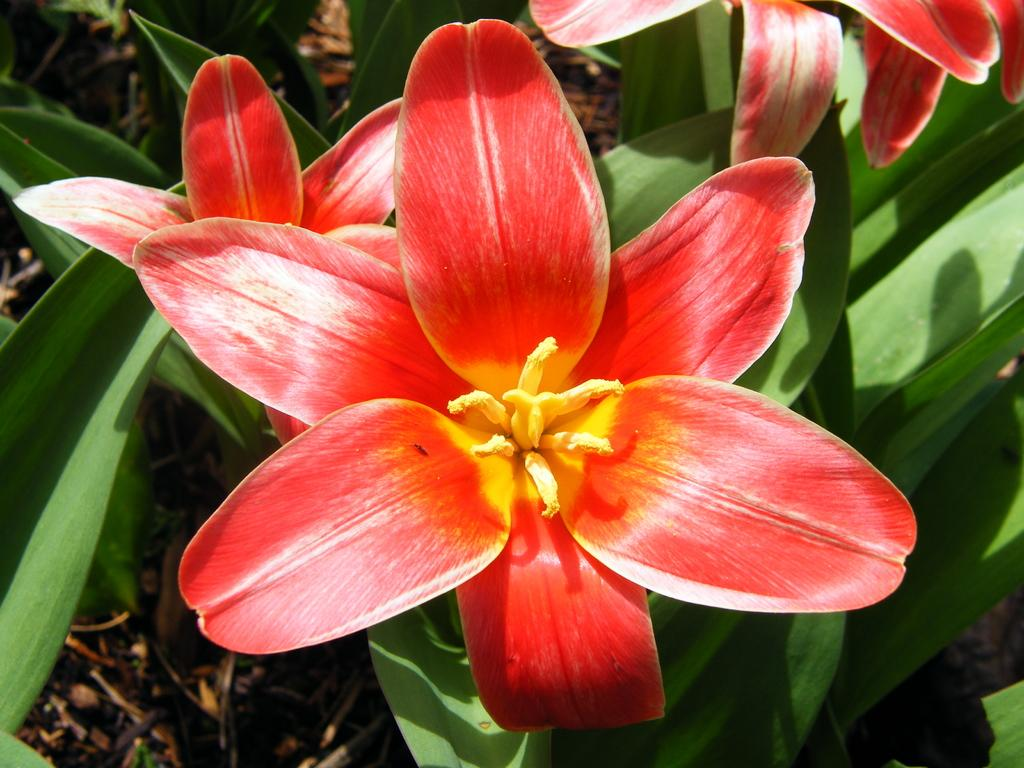What type of vegetation can be seen in the image? There are flowers and plants in the image. What is covering the ground in the image? Shredded leaves are present on the ground in the image. What type of bean is being served on a plate in the image? There is no bean or plate present in the image; it features flowers, plants, and shredded leaves on the ground. What kind of toys can be seen in the image? There are no toys present in the image. 